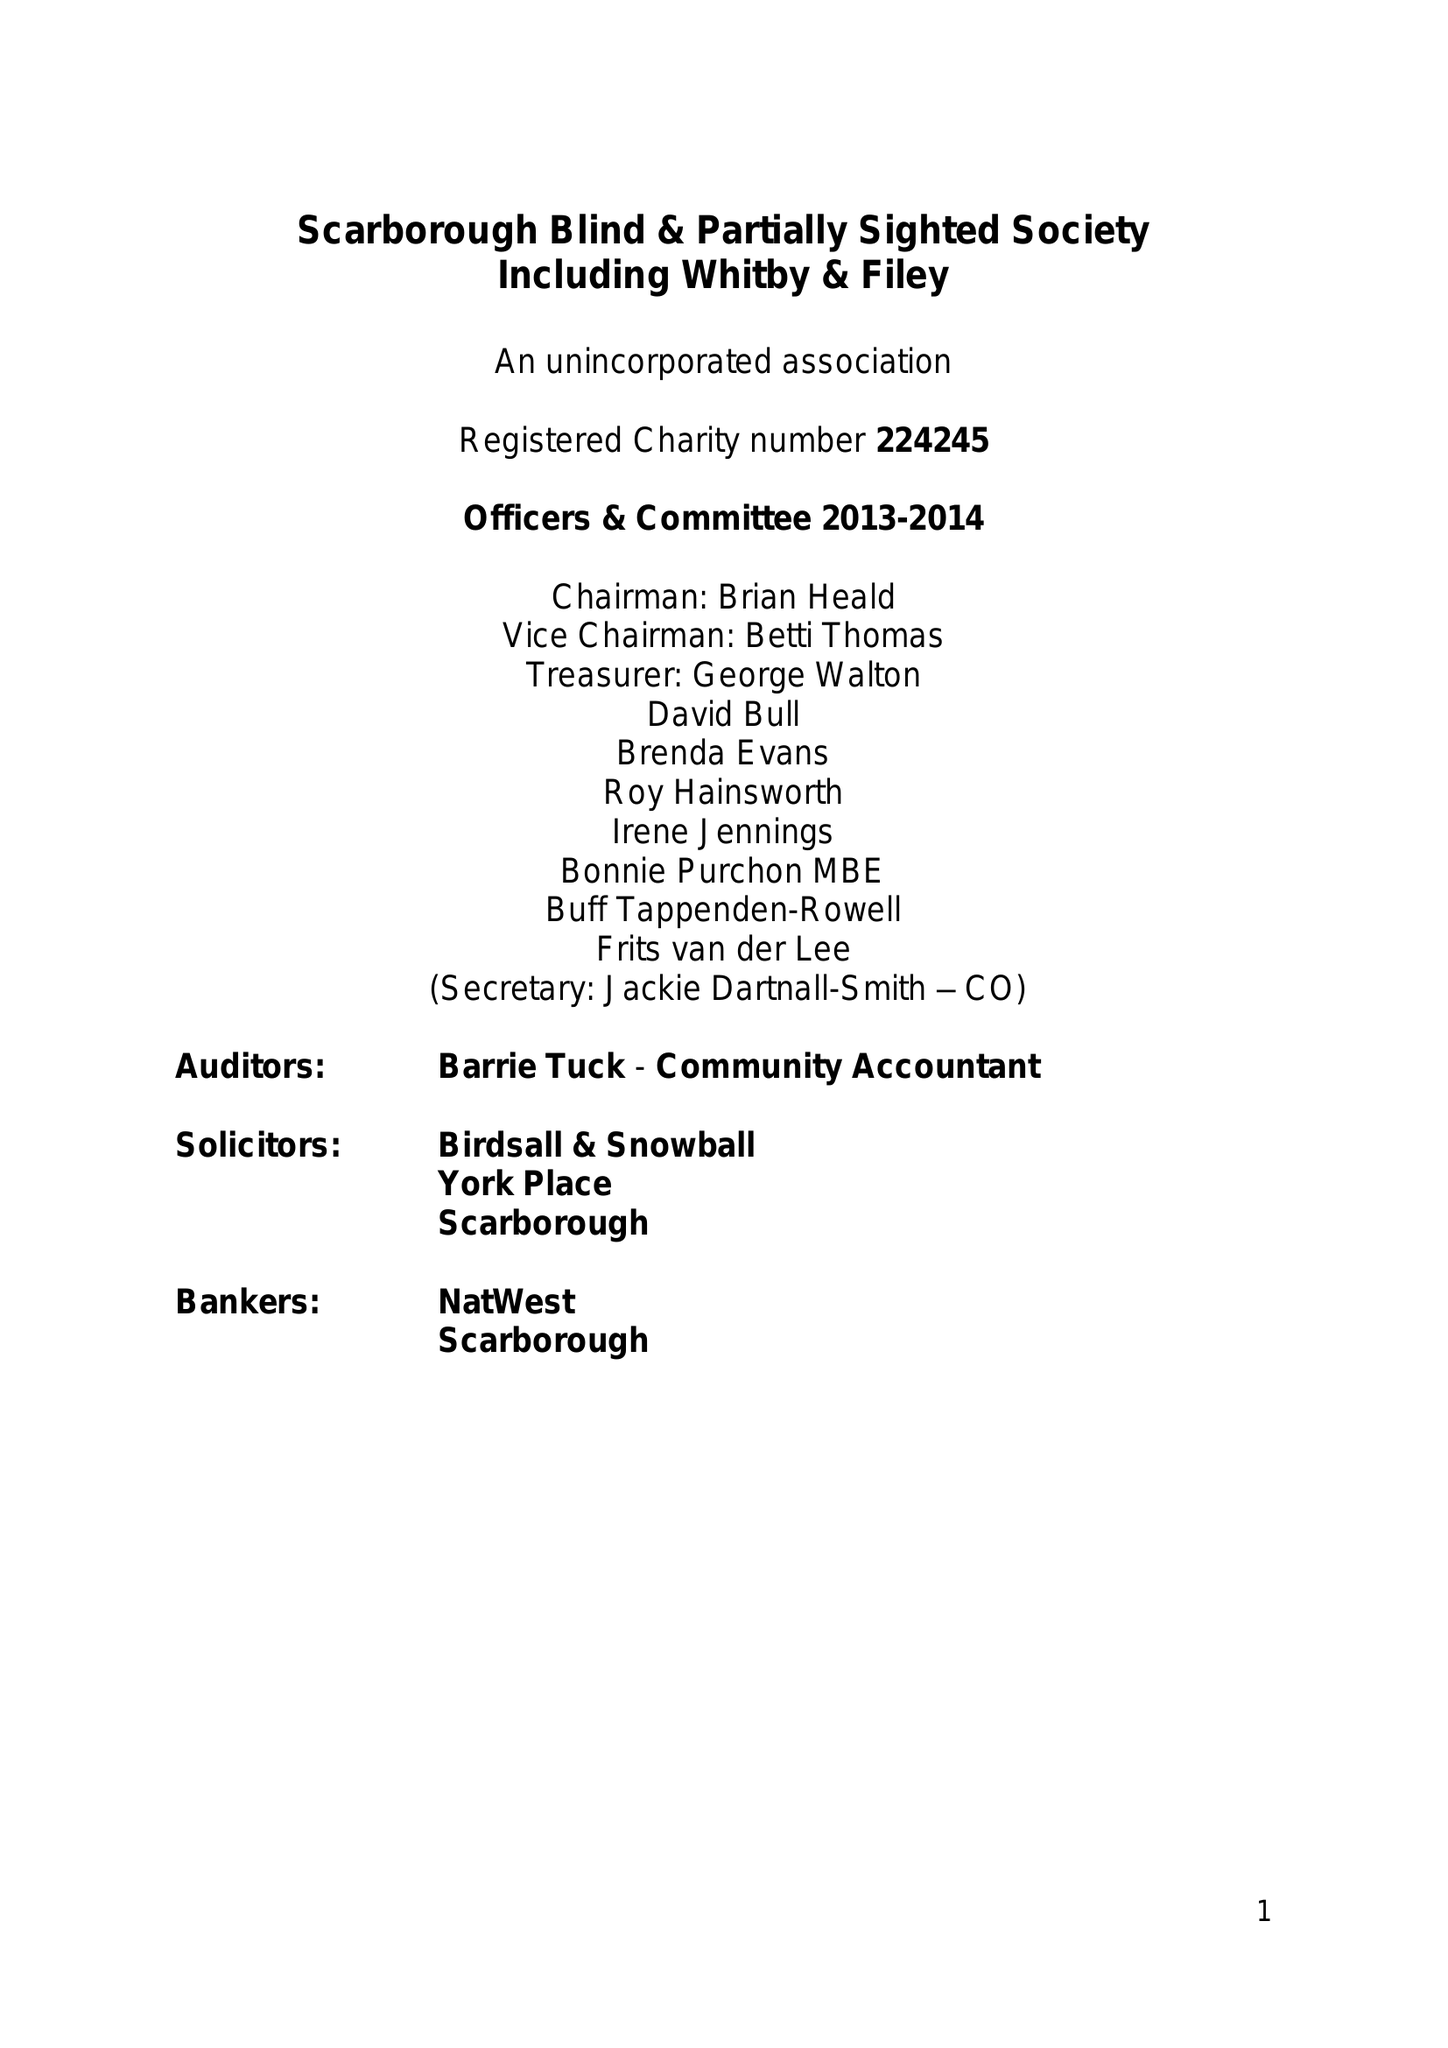What is the value for the address__post_town?
Answer the question using a single word or phrase. SCARBOROUGH 